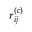<formula> <loc_0><loc_0><loc_500><loc_500>r _ { i j } ^ { ( c ) }</formula> 